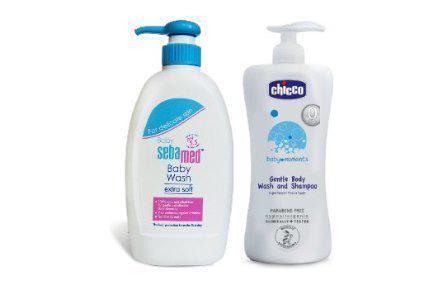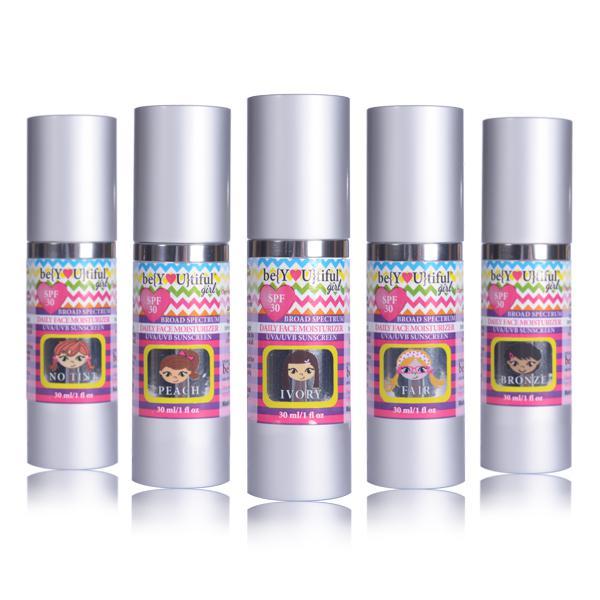The first image is the image on the left, the second image is the image on the right. Assess this claim about the two images: "In at least one image there is a total of two wash bottles.". Correct or not? Answer yes or no. Yes. The first image is the image on the left, the second image is the image on the right. For the images shown, is this caption "The lefthand image includes a pump-applicator bottle, while the right image contains at least four versions of one product that doesn't have a pump top." true? Answer yes or no. Yes. 